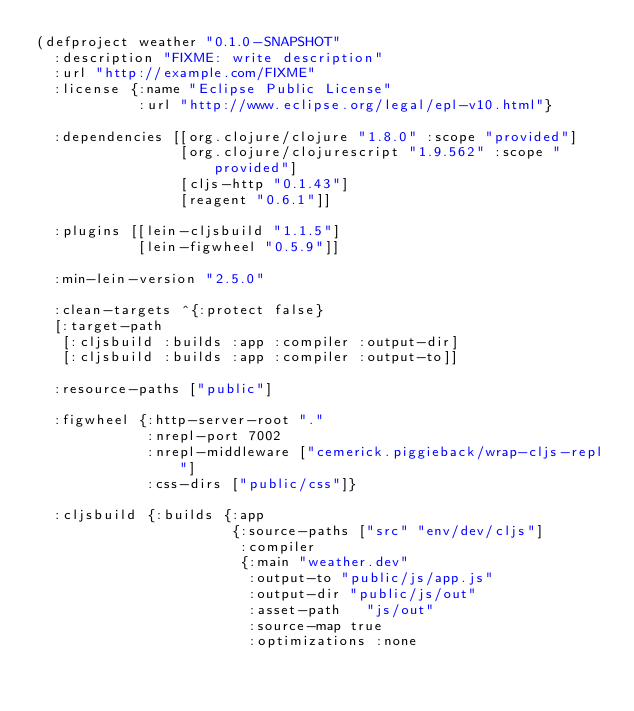Convert code to text. <code><loc_0><loc_0><loc_500><loc_500><_Clojure_>(defproject weather "0.1.0-SNAPSHOT"
  :description "FIXME: write description"
  :url "http://example.com/FIXME"
  :license {:name "Eclipse Public License"
            :url "http://www.eclipse.org/legal/epl-v10.html"}

  :dependencies [[org.clojure/clojure "1.8.0" :scope "provided"]
                 [org.clojure/clojurescript "1.9.562" :scope "provided"]
                 [cljs-http "0.1.43"]
                 [reagent "0.6.1"]]

  :plugins [[lein-cljsbuild "1.1.5"]
            [lein-figwheel "0.5.9"]]

  :min-lein-version "2.5.0"

  :clean-targets ^{:protect false}
  [:target-path
   [:cljsbuild :builds :app :compiler :output-dir]
   [:cljsbuild :builds :app :compiler :output-to]]

  :resource-paths ["public"]

  :figwheel {:http-server-root "."
             :nrepl-port 7002
             :nrepl-middleware ["cemerick.piggieback/wrap-cljs-repl"]
             :css-dirs ["public/css"]}

  :cljsbuild {:builds {:app
                       {:source-paths ["src" "env/dev/cljs"]
                        :compiler
                        {:main "weather.dev"
                         :output-to "public/js/app.js"
                         :output-dir "public/js/out"
                         :asset-path   "js/out"
                         :source-map true
                         :optimizations :none</code> 